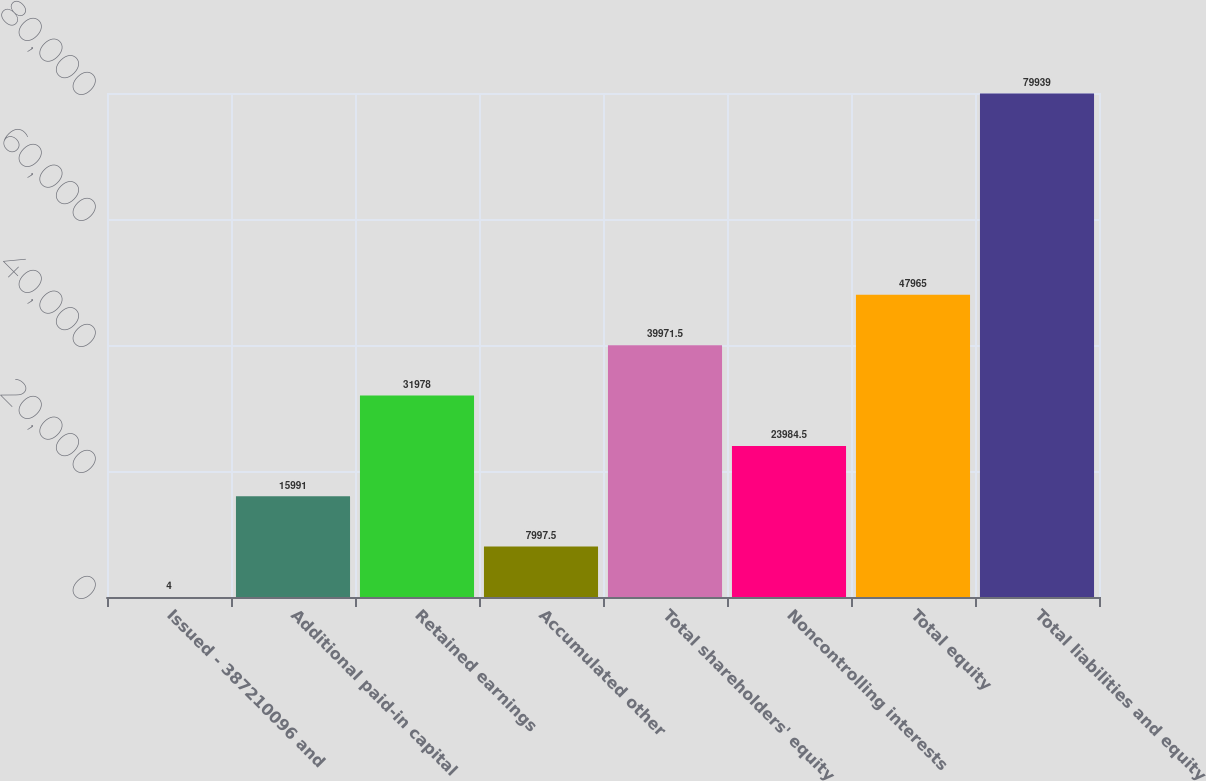Convert chart to OTSL. <chart><loc_0><loc_0><loc_500><loc_500><bar_chart><fcel>Issued - 387210096 and<fcel>Additional paid-in capital<fcel>Retained earnings<fcel>Accumulated other<fcel>Total shareholders' equity<fcel>Noncontrolling interests<fcel>Total equity<fcel>Total liabilities and equity<nl><fcel>4<fcel>15991<fcel>31978<fcel>7997.5<fcel>39971.5<fcel>23984.5<fcel>47965<fcel>79939<nl></chart> 